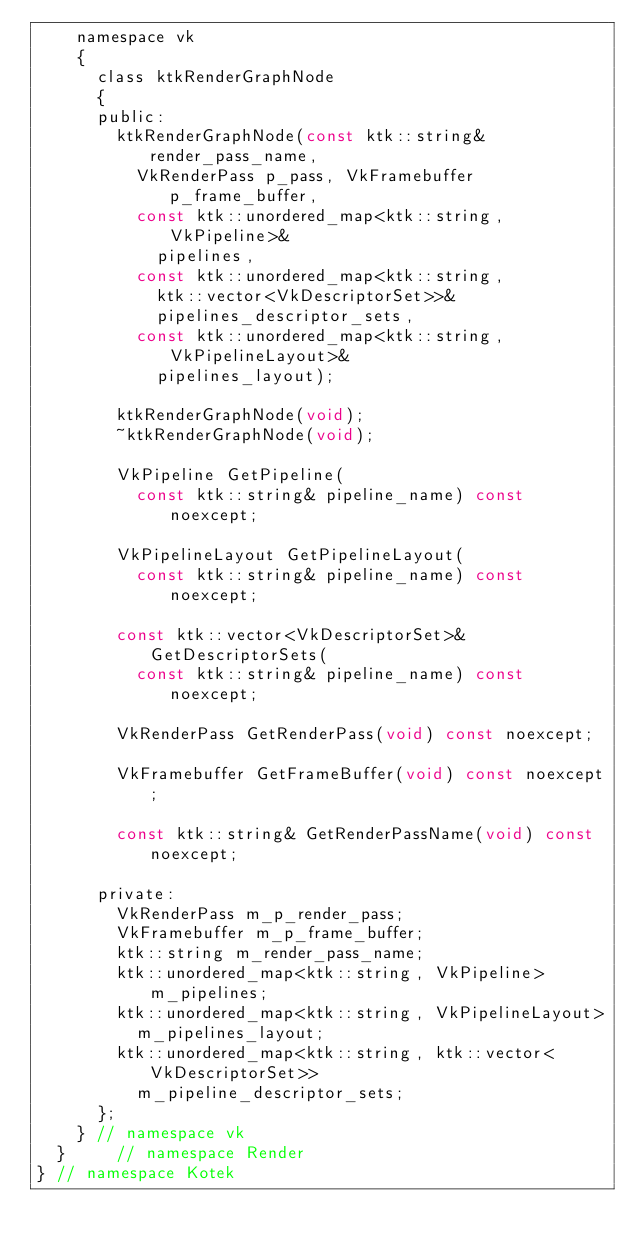Convert code to text. <code><loc_0><loc_0><loc_500><loc_500><_C_>		namespace vk
		{
			class ktkRenderGraphNode
			{
			public:
				ktkRenderGraphNode(const ktk::string& render_pass_name,
					VkRenderPass p_pass, VkFramebuffer p_frame_buffer,
					const ktk::unordered_map<ktk::string, VkPipeline>&
						pipelines,
					const ktk::unordered_map<ktk::string,
						ktk::vector<VkDescriptorSet>>&
						pipelines_descriptor_sets,
					const ktk::unordered_map<ktk::string, VkPipelineLayout>&
						pipelines_layout);

				ktkRenderGraphNode(void);
				~ktkRenderGraphNode(void);

				VkPipeline GetPipeline(
					const ktk::string& pipeline_name) const noexcept;

				VkPipelineLayout GetPipelineLayout(
					const ktk::string& pipeline_name) const noexcept;

				const ktk::vector<VkDescriptorSet>& GetDescriptorSets(
					const ktk::string& pipeline_name) const noexcept;

				VkRenderPass GetRenderPass(void) const noexcept;

				VkFramebuffer GetFrameBuffer(void) const noexcept;

				const ktk::string& GetRenderPassName(void) const noexcept;

			private:
				VkRenderPass m_p_render_pass;
				VkFramebuffer m_p_frame_buffer;
				ktk::string m_render_pass_name;
				ktk::unordered_map<ktk::string, VkPipeline> m_pipelines;
				ktk::unordered_map<ktk::string, VkPipelineLayout>
					m_pipelines_layout;
				ktk::unordered_map<ktk::string, ktk::vector<VkDescriptorSet>>
					m_pipeline_descriptor_sets;
			};
		} // namespace vk
	}     // namespace Render
} // namespace Kotek</code> 